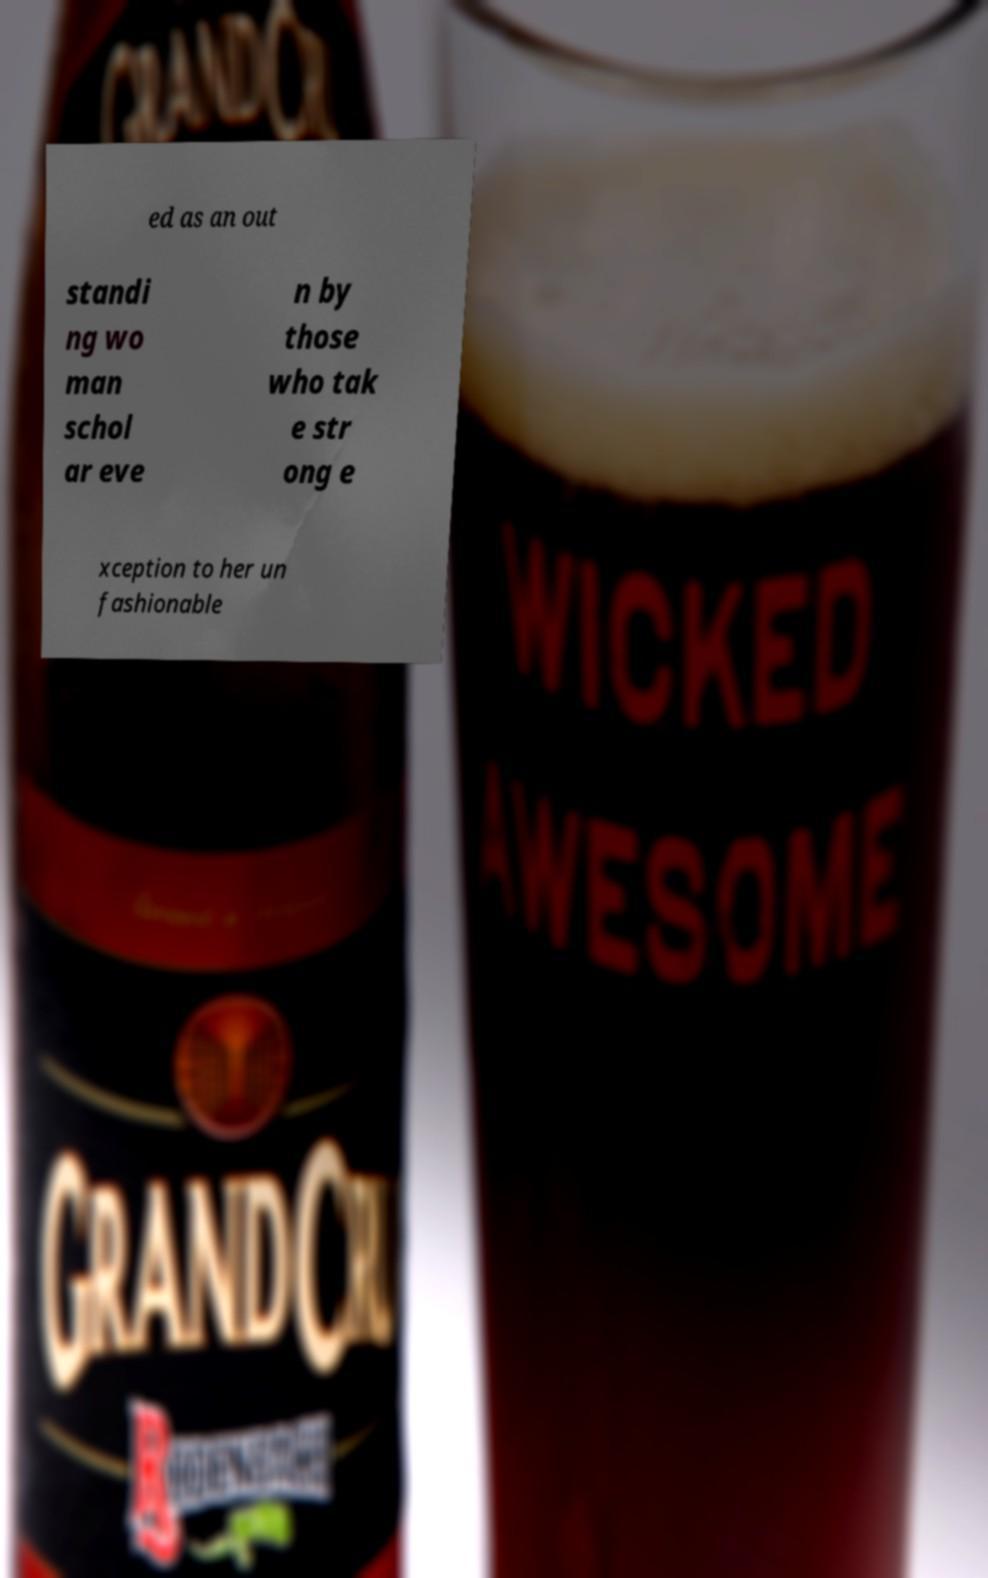Please identify and transcribe the text found in this image. ed as an out standi ng wo man schol ar eve n by those who tak e str ong e xception to her un fashionable 